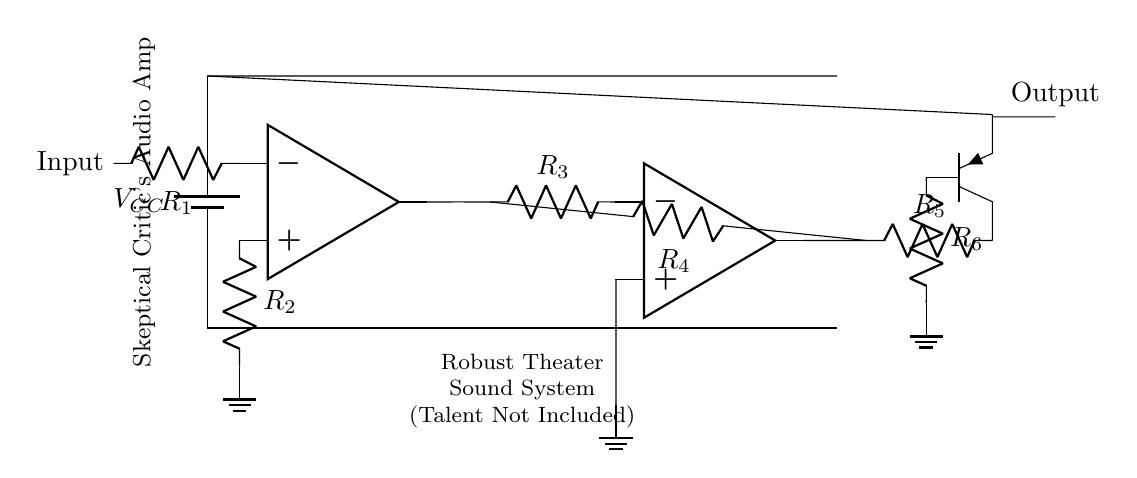What is the main component used for amplification? The main component for amplification in the circuit is the operational amplifier, indicated as "op amp." It takes a small input signal and produces a larger output signal, essential for audio amplification.
Answer: operational amplifier What resistance values are used in the feedback loop? The feedback loop involves resistors R3 and R4, which form part of the gain-setting part of the amplifier. This configuration is essential in determining the overall gain of the amplifier circuit.
Answer: R3 and R4 How many input and output stages are present in the circuit? The circuit contains one input stage and one output stage. The input stage includes the first operational amplifier and related components, while the output stage is where the signal is sent out after amplification.
Answer: 1 input and 1 output stage What is the power supply voltage denoted as? The power supply voltage in the circuit is denoted as V_CC, which signifies the voltage that powers the operational amplifiers and other components in the circuit.
Answer: V_CC What type of transistor is used in the output stage? In the output stage, a PNP transistor is used, labeled as Q1. This type of transistor is typically employed for its characteristics suitable for audio applications, providing the necessary current to drive the speakers.
Answer: PNP transistor What is the connection between R1 and the operational amplifier? Resistor R1 is connected to the inverting input of the operational amplifier. It sets the input impedance and works with resistor R2 to establish the desired gain in the input stage.
Answer: R1 connects to the inverting input What does the label "Skeptical Critic's Audio Amp" suggest about the circuit's design? The label implies that the circuit is tailored for high-quality audio amplification, possibly highlighting the robustness of the design against common audio problems, reflecting the critical nature of performance in theater settings.
Answer: high-quality audio amplification 